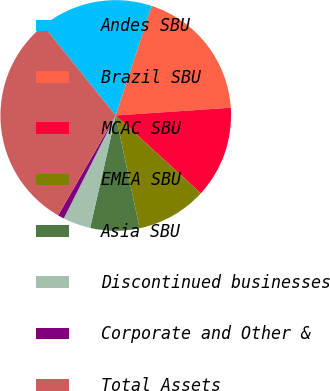Convert chart. <chart><loc_0><loc_0><loc_500><loc_500><pie_chart><fcel>Andes SBU<fcel>Brazil SBU<fcel>MCAC SBU<fcel>EMEA SBU<fcel>Asia SBU<fcel>Discontinued businesses<fcel>Corporate and Other &<fcel>Total Assets<nl><fcel>15.87%<fcel>18.87%<fcel>12.87%<fcel>9.88%<fcel>6.88%<fcel>3.88%<fcel>0.88%<fcel>30.87%<nl></chart> 